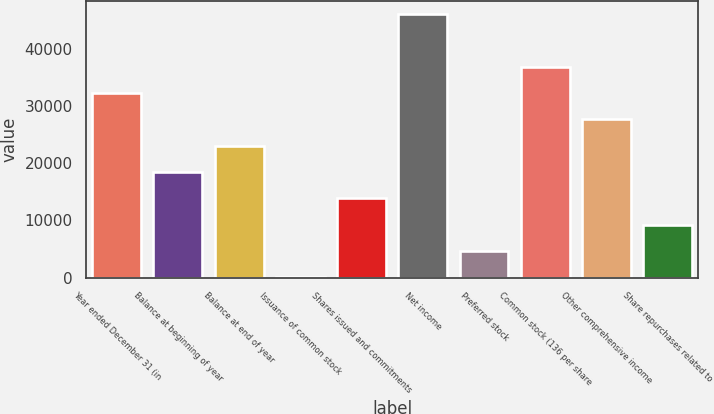<chart> <loc_0><loc_0><loc_500><loc_500><bar_chart><fcel>Year ended December 31 (in<fcel>Balance at beginning of year<fcel>Balance at end of year<fcel>Issuance of common stock<fcel>Shares issued and commitments<fcel>Net income<fcel>Preferred stock<fcel>Common stock (136 per share<fcel>Other comprehensive income<fcel>Share repurchases related to<nl><fcel>32313.8<fcel>18473.6<fcel>23087<fcel>20<fcel>13860.2<fcel>46154<fcel>4633.4<fcel>36927.2<fcel>27700.4<fcel>9246.8<nl></chart> 